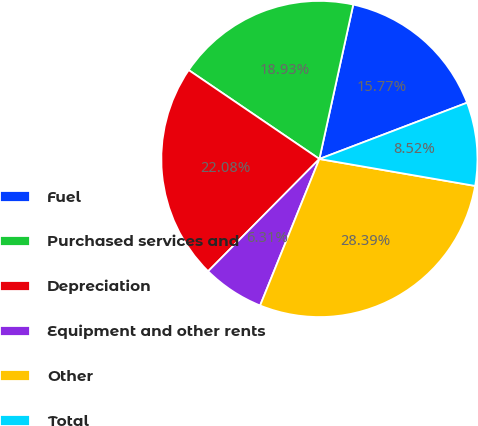Convert chart. <chart><loc_0><loc_0><loc_500><loc_500><pie_chart><fcel>Fuel<fcel>Purchased services and<fcel>Depreciation<fcel>Equipment and other rents<fcel>Other<fcel>Total<nl><fcel>15.77%<fcel>18.93%<fcel>22.08%<fcel>6.31%<fcel>28.39%<fcel>8.52%<nl></chart> 